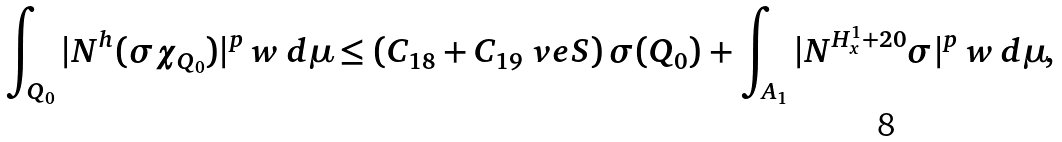Convert formula to latex. <formula><loc_0><loc_0><loc_500><loc_500>\int _ { Q _ { 0 } } | N ^ { h } ( \sigma \chi _ { Q _ { 0 } } ) | ^ { p } \, w \, d \mu \leq ( C _ { 1 8 } + C _ { 1 9 } \ v e S ) \, \sigma ( Q _ { 0 } ) + \int _ { A _ { 1 } } | N ^ { H ^ { 1 } _ { x } + 2 0 } \sigma | ^ { p } \, w \, d \mu ,</formula> 